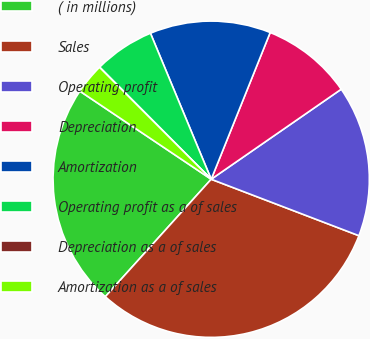Convert chart to OTSL. <chart><loc_0><loc_0><loc_500><loc_500><pie_chart><fcel>( in millions)<fcel>Sales<fcel>Operating profit<fcel>Depreciation<fcel>Amortization<fcel>Operating profit as a of sales<fcel>Depreciation as a of sales<fcel>Amortization as a of sales<nl><fcel>22.73%<fcel>30.87%<fcel>15.45%<fcel>9.28%<fcel>12.36%<fcel>6.19%<fcel>0.02%<fcel>3.11%<nl></chart> 